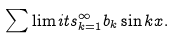<formula> <loc_0><loc_0><loc_500><loc_500>\sum \lim i t s _ { k = 1 } ^ { \infty } b _ { k } \sin k x .</formula> 